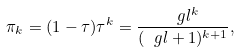Convert formula to latex. <formula><loc_0><loc_0><loc_500><loc_500>\pi _ { k } = ( 1 - \tau ) \tau ^ { k } = \frac { \ g l ^ { k } } { ( \ g l + 1 ) ^ { k + 1 } } ,</formula> 